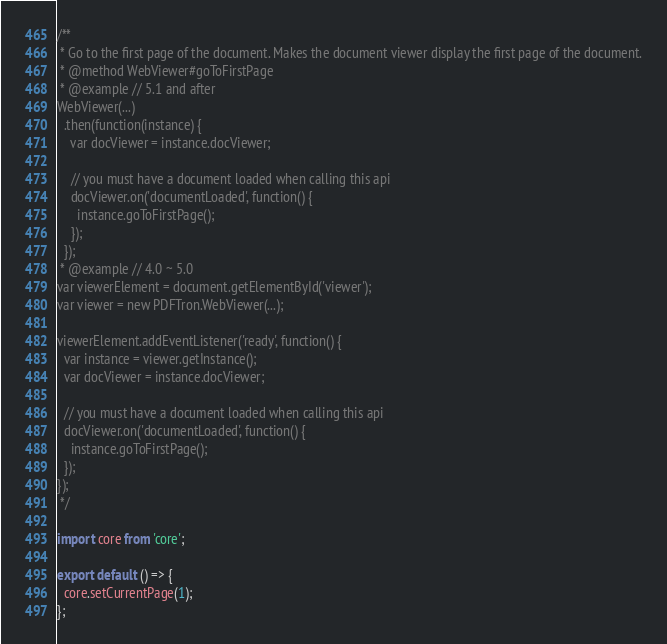<code> <loc_0><loc_0><loc_500><loc_500><_JavaScript_>/**
 * Go to the first page of the document. Makes the document viewer display the first page of the document.
 * @method WebViewer#goToFirstPage
 * @example // 5.1 and after
WebViewer(...)
  .then(function(instance) {
    var docViewer = instance.docViewer;

    // you must have a document loaded when calling this api
    docViewer.on('documentLoaded', function() {
      instance.goToFirstPage();
    });
  });
 * @example // 4.0 ~ 5.0
var viewerElement = document.getElementById('viewer');
var viewer = new PDFTron.WebViewer(...);

viewerElement.addEventListener('ready', function() {
  var instance = viewer.getInstance();
  var docViewer = instance.docViewer;

  // you must have a document loaded when calling this api
  docViewer.on('documentLoaded', function() {
    instance.goToFirstPage();
  });
});
 */

import core from 'core';

export default () => {
  core.setCurrentPage(1);
};
</code> 